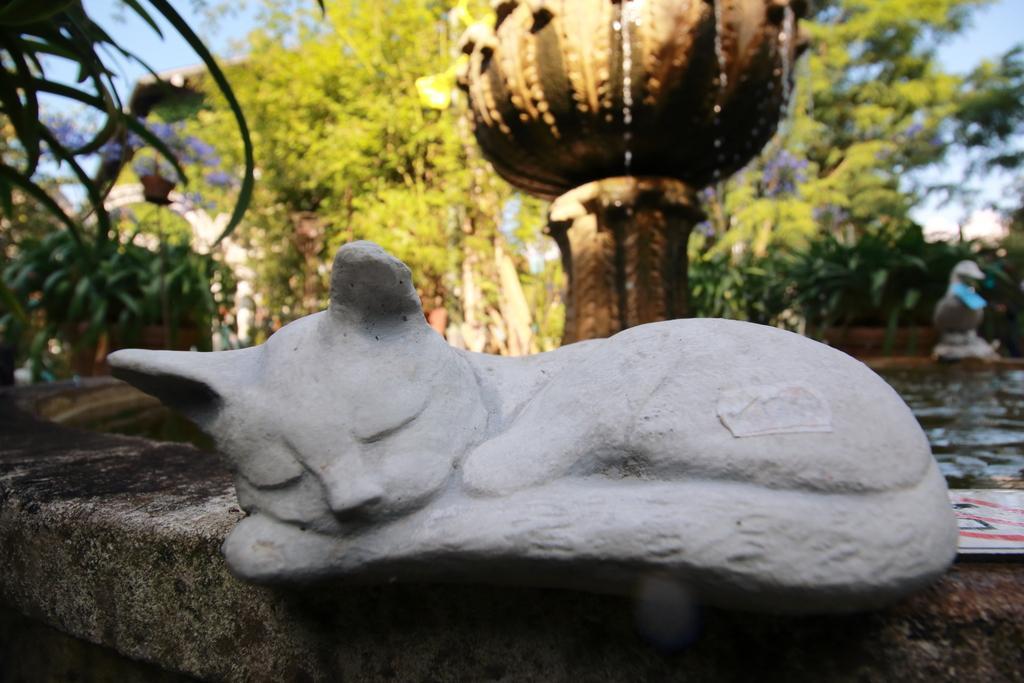How would you summarize this image in a sentence or two? In this image in the foreground there is a sculpture of a cat, and in the background there is some object, trees, plants and some flower pots. At the bottom there is wall, and at top of the image there is sky and also we could see some water in the center and some statues. 